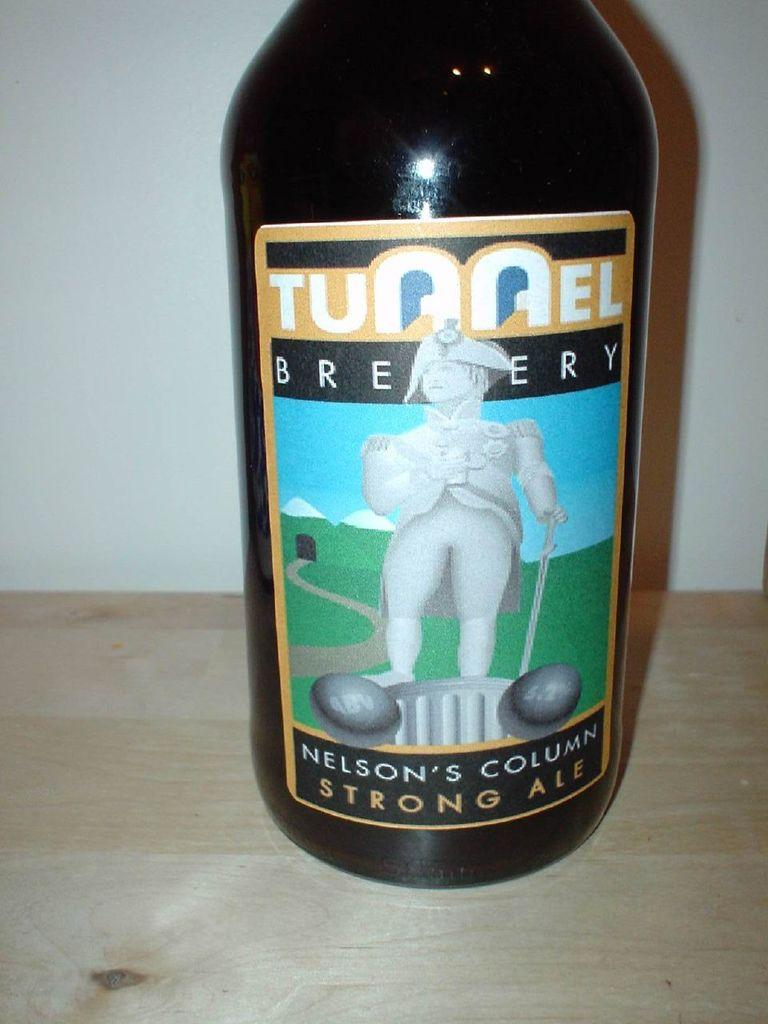<image>
Give a short and clear explanation of the subsequent image. A bottle of Tunnel Brewery Nelson's Column Strong Ale 